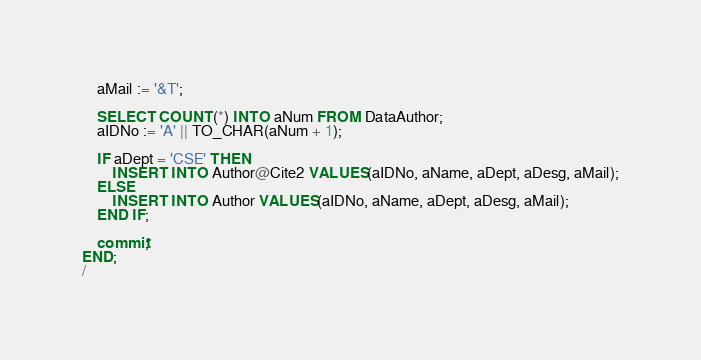<code> <loc_0><loc_0><loc_500><loc_500><_SQL_>    aMail := '&T';

    SELECT COUNT(*) INTO aNum FROM DataAuthor;
    aIDNo := 'A' || TO_CHAR(aNum + 1);

    IF aDept = 'CSE' THEN
        INSERT INTO Author@Cite2 VALUES(aIDNo, aName, aDept, aDesg, aMail);
    ELSE
        INSERT INTO Author VALUES(aIDNo, aName, aDept, aDesg, aMail);
    END IF;

    commit;
END;
/</code> 